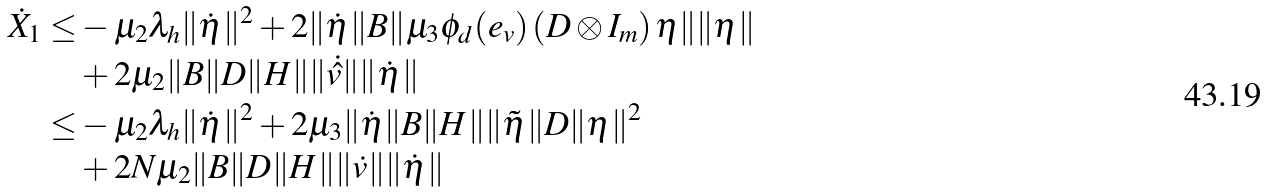Convert formula to latex. <formula><loc_0><loc_0><loc_500><loc_500>\dot { X } _ { 1 } \leq & - \mu _ { 2 } \lambda _ { h } \| \dot { \eta } \| ^ { 2 } + 2 \| \dot { \eta } \| B \| \mu _ { 3 } \phi _ { d } ( e _ { v } ) \left ( D \otimes I _ { m } \right ) \eta \| \| \eta \| \\ & + 2 \mu _ { 2 } \| B \| D \| H \| \| \dot { \hat { v } } \| \| \dot { \eta } \| \\ \leq & - \mu _ { 2 } \lambda _ { h } \| \dot { \eta } \| ^ { 2 } + 2 \mu _ { 3 } \| \dot { \eta } \| B \| H \| \| \tilde { \eta } \| D \| \eta \| ^ { 2 } \\ & + 2 N \mu _ { 2 } \| B \| D \| H \| \| \dot { v } \| \| \dot { \eta } \|</formula> 